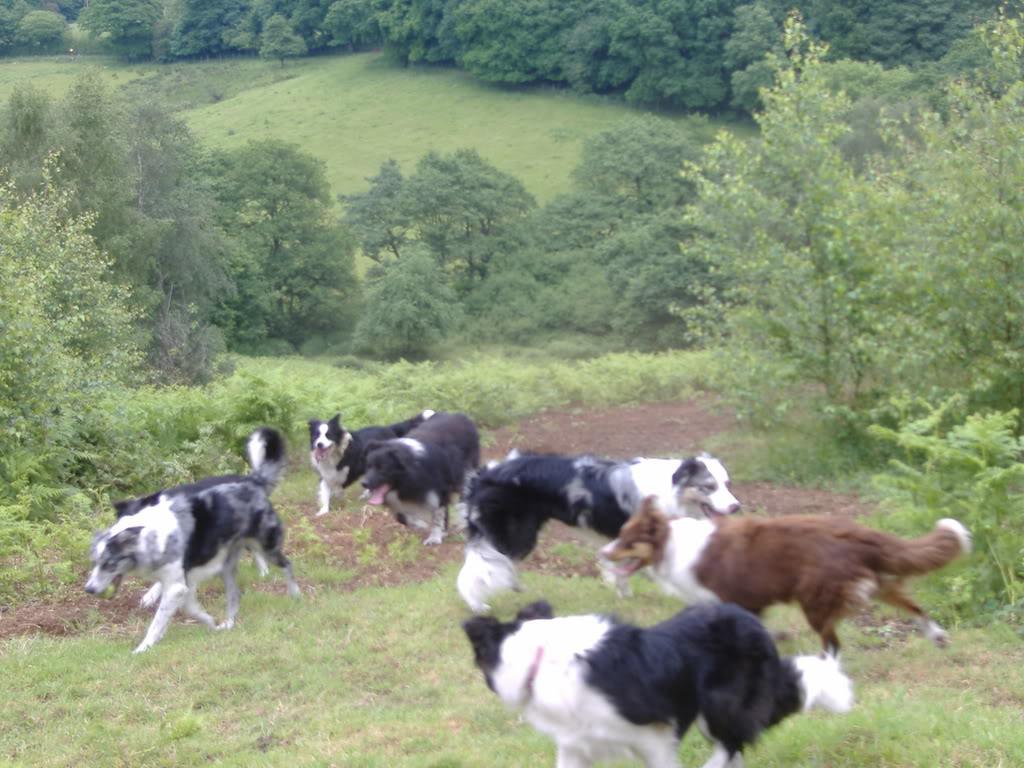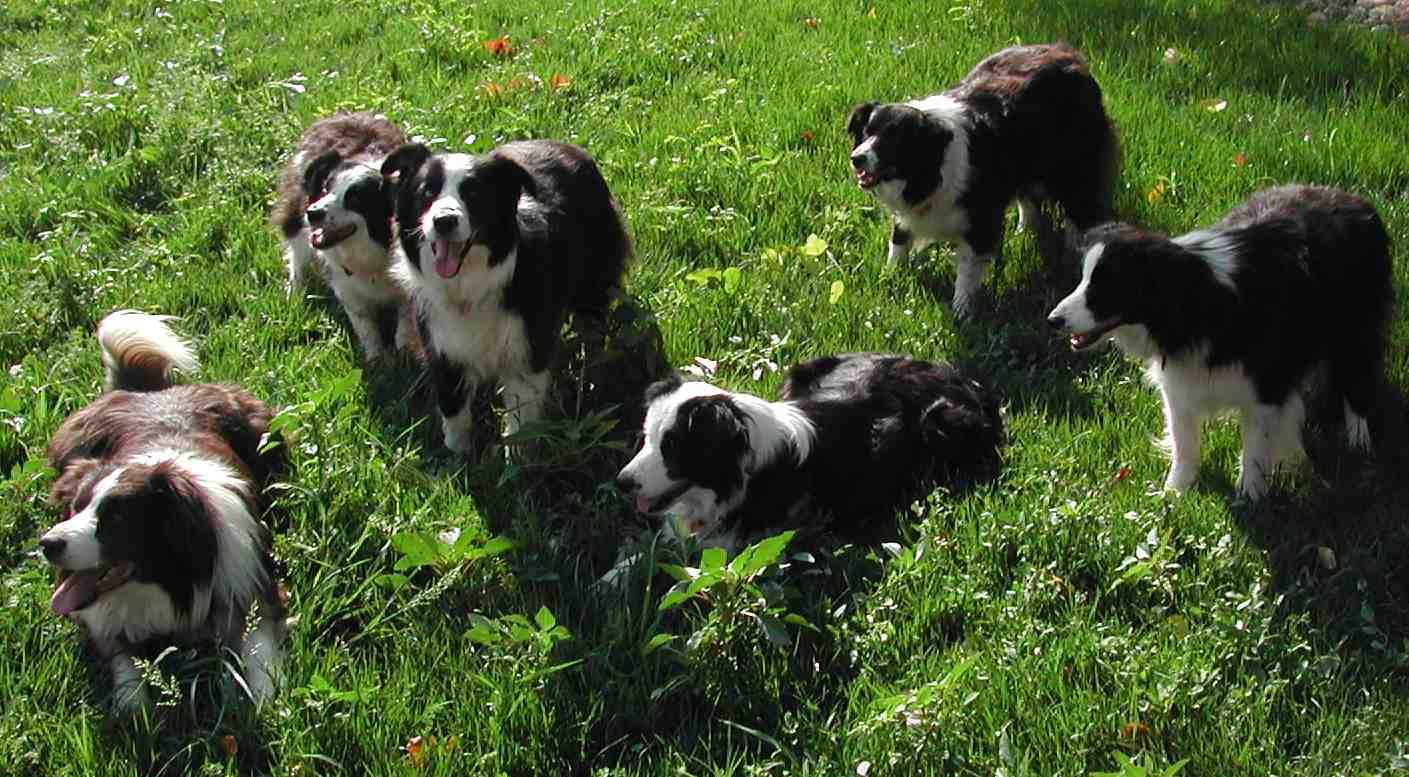The first image is the image on the left, the second image is the image on the right. Examine the images to the left and right. Is the description "An image shows a straight row of at least seven dogs reclining on the grass." accurate? Answer yes or no. No. The first image is the image on the left, the second image is the image on the right. Examine the images to the left and right. Is the description "There are at most 5 dogs on the left image." accurate? Answer yes or no. No. 